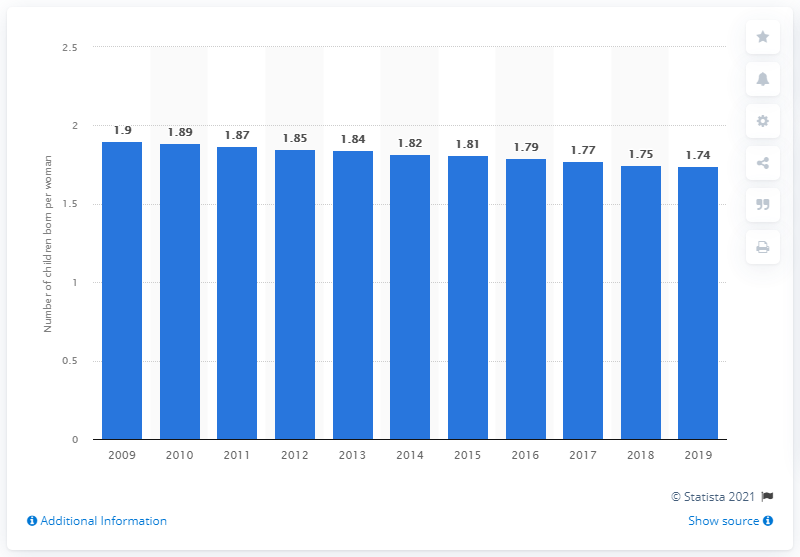Highlight a few significant elements in this photo. The fertility rate in Costa Rica in 2019 was 1.74. 